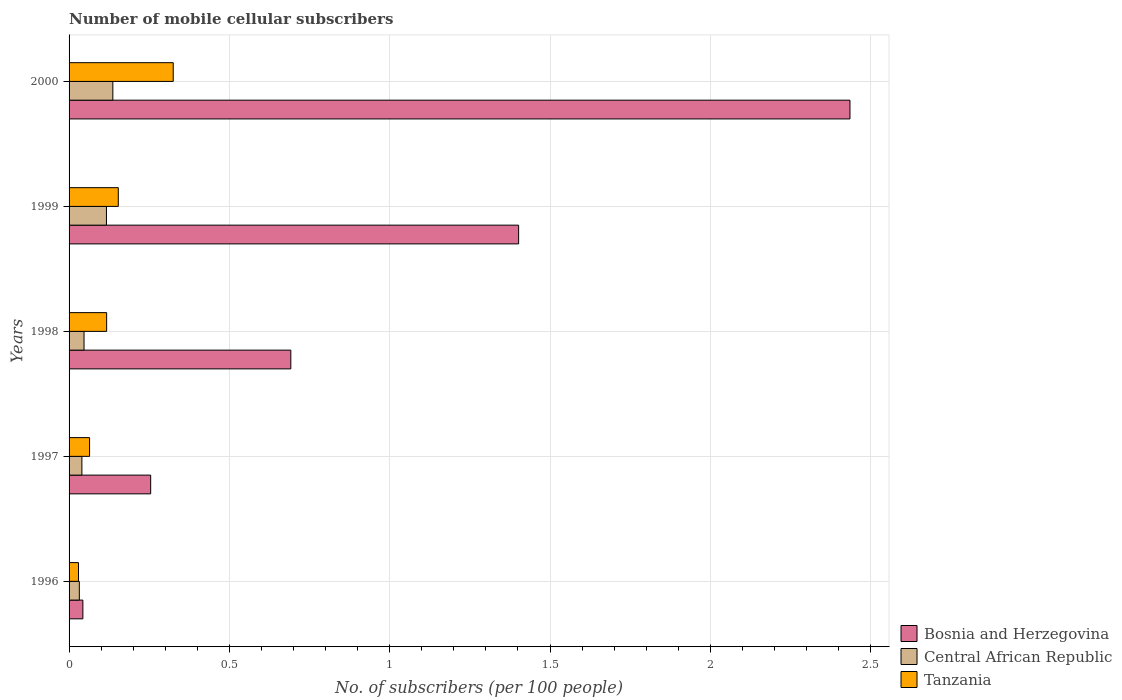How many bars are there on the 5th tick from the top?
Give a very brief answer. 3. How many bars are there on the 5th tick from the bottom?
Ensure brevity in your answer.  3. What is the label of the 5th group of bars from the top?
Ensure brevity in your answer.  1996. What is the number of mobile cellular subscribers in Tanzania in 2000?
Make the answer very short. 0.32. Across all years, what is the maximum number of mobile cellular subscribers in Tanzania?
Your answer should be very brief. 0.32. Across all years, what is the minimum number of mobile cellular subscribers in Tanzania?
Your answer should be very brief. 0.03. What is the total number of mobile cellular subscribers in Central African Republic in the graph?
Keep it short and to the point. 0.37. What is the difference between the number of mobile cellular subscribers in Bosnia and Herzegovina in 1997 and that in 1998?
Give a very brief answer. -0.44. What is the difference between the number of mobile cellular subscribers in Bosnia and Herzegovina in 1998 and the number of mobile cellular subscribers in Tanzania in 1999?
Offer a very short reply. 0.54. What is the average number of mobile cellular subscribers in Central African Republic per year?
Give a very brief answer. 0.07. In the year 1996, what is the difference between the number of mobile cellular subscribers in Bosnia and Herzegovina and number of mobile cellular subscribers in Tanzania?
Ensure brevity in your answer.  0.01. In how many years, is the number of mobile cellular subscribers in Central African Republic greater than 1 ?
Provide a succinct answer. 0. What is the ratio of the number of mobile cellular subscribers in Tanzania in 1996 to that in 1998?
Your response must be concise. 0.25. Is the difference between the number of mobile cellular subscribers in Bosnia and Herzegovina in 1997 and 1999 greater than the difference between the number of mobile cellular subscribers in Tanzania in 1997 and 1999?
Ensure brevity in your answer.  No. What is the difference between the highest and the second highest number of mobile cellular subscribers in Central African Republic?
Offer a very short reply. 0.02. What is the difference between the highest and the lowest number of mobile cellular subscribers in Central African Republic?
Ensure brevity in your answer.  0.1. In how many years, is the number of mobile cellular subscribers in Bosnia and Herzegovina greater than the average number of mobile cellular subscribers in Bosnia and Herzegovina taken over all years?
Ensure brevity in your answer.  2. What does the 3rd bar from the top in 1999 represents?
Provide a succinct answer. Bosnia and Herzegovina. What does the 1st bar from the bottom in 1998 represents?
Give a very brief answer. Bosnia and Herzegovina. Are all the bars in the graph horizontal?
Offer a terse response. Yes. How many years are there in the graph?
Give a very brief answer. 5. Are the values on the major ticks of X-axis written in scientific E-notation?
Provide a succinct answer. No. Does the graph contain any zero values?
Provide a short and direct response. No. Does the graph contain grids?
Your answer should be very brief. Yes. How many legend labels are there?
Ensure brevity in your answer.  3. What is the title of the graph?
Make the answer very short. Number of mobile cellular subscribers. What is the label or title of the X-axis?
Ensure brevity in your answer.  No. of subscribers (per 100 people). What is the No. of subscribers (per 100 people) of Bosnia and Herzegovina in 1996?
Provide a short and direct response. 0.04. What is the No. of subscribers (per 100 people) of Central African Republic in 1996?
Ensure brevity in your answer.  0.03. What is the No. of subscribers (per 100 people) in Tanzania in 1996?
Your answer should be very brief. 0.03. What is the No. of subscribers (per 100 people) of Bosnia and Herzegovina in 1997?
Your answer should be very brief. 0.25. What is the No. of subscribers (per 100 people) of Central African Republic in 1997?
Your response must be concise. 0.04. What is the No. of subscribers (per 100 people) in Tanzania in 1997?
Provide a succinct answer. 0.06. What is the No. of subscribers (per 100 people) of Bosnia and Herzegovina in 1998?
Provide a short and direct response. 0.69. What is the No. of subscribers (per 100 people) in Central African Republic in 1998?
Give a very brief answer. 0.05. What is the No. of subscribers (per 100 people) of Tanzania in 1998?
Offer a very short reply. 0.12. What is the No. of subscribers (per 100 people) in Bosnia and Herzegovina in 1999?
Your response must be concise. 1.4. What is the No. of subscribers (per 100 people) in Central African Republic in 1999?
Keep it short and to the point. 0.12. What is the No. of subscribers (per 100 people) of Tanzania in 1999?
Your response must be concise. 0.15. What is the No. of subscribers (per 100 people) of Bosnia and Herzegovina in 2000?
Your answer should be very brief. 2.44. What is the No. of subscribers (per 100 people) of Central African Republic in 2000?
Keep it short and to the point. 0.14. What is the No. of subscribers (per 100 people) of Tanzania in 2000?
Offer a very short reply. 0.32. Across all years, what is the maximum No. of subscribers (per 100 people) in Bosnia and Herzegovina?
Your response must be concise. 2.44. Across all years, what is the maximum No. of subscribers (per 100 people) in Central African Republic?
Your answer should be compact. 0.14. Across all years, what is the maximum No. of subscribers (per 100 people) of Tanzania?
Give a very brief answer. 0.32. Across all years, what is the minimum No. of subscribers (per 100 people) in Bosnia and Herzegovina?
Keep it short and to the point. 0.04. Across all years, what is the minimum No. of subscribers (per 100 people) in Central African Republic?
Your answer should be compact. 0.03. Across all years, what is the minimum No. of subscribers (per 100 people) in Tanzania?
Your response must be concise. 0.03. What is the total No. of subscribers (per 100 people) in Bosnia and Herzegovina in the graph?
Keep it short and to the point. 4.83. What is the total No. of subscribers (per 100 people) of Central African Republic in the graph?
Make the answer very short. 0.37. What is the total No. of subscribers (per 100 people) in Tanzania in the graph?
Provide a short and direct response. 0.69. What is the difference between the No. of subscribers (per 100 people) in Bosnia and Herzegovina in 1996 and that in 1997?
Make the answer very short. -0.21. What is the difference between the No. of subscribers (per 100 people) in Central African Republic in 1996 and that in 1997?
Provide a short and direct response. -0.01. What is the difference between the No. of subscribers (per 100 people) in Tanzania in 1996 and that in 1997?
Give a very brief answer. -0.03. What is the difference between the No. of subscribers (per 100 people) of Bosnia and Herzegovina in 1996 and that in 1998?
Your response must be concise. -0.65. What is the difference between the No. of subscribers (per 100 people) of Central African Republic in 1996 and that in 1998?
Make the answer very short. -0.01. What is the difference between the No. of subscribers (per 100 people) of Tanzania in 1996 and that in 1998?
Offer a terse response. -0.09. What is the difference between the No. of subscribers (per 100 people) of Bosnia and Herzegovina in 1996 and that in 1999?
Make the answer very short. -1.36. What is the difference between the No. of subscribers (per 100 people) of Central African Republic in 1996 and that in 1999?
Give a very brief answer. -0.08. What is the difference between the No. of subscribers (per 100 people) of Tanzania in 1996 and that in 1999?
Give a very brief answer. -0.12. What is the difference between the No. of subscribers (per 100 people) in Bosnia and Herzegovina in 1996 and that in 2000?
Give a very brief answer. -2.39. What is the difference between the No. of subscribers (per 100 people) of Central African Republic in 1996 and that in 2000?
Offer a very short reply. -0.1. What is the difference between the No. of subscribers (per 100 people) of Tanzania in 1996 and that in 2000?
Your response must be concise. -0.3. What is the difference between the No. of subscribers (per 100 people) in Bosnia and Herzegovina in 1997 and that in 1998?
Offer a very short reply. -0.44. What is the difference between the No. of subscribers (per 100 people) of Central African Republic in 1997 and that in 1998?
Your answer should be compact. -0.01. What is the difference between the No. of subscribers (per 100 people) of Tanzania in 1997 and that in 1998?
Your answer should be very brief. -0.05. What is the difference between the No. of subscribers (per 100 people) in Bosnia and Herzegovina in 1997 and that in 1999?
Provide a short and direct response. -1.15. What is the difference between the No. of subscribers (per 100 people) in Central African Republic in 1997 and that in 1999?
Give a very brief answer. -0.08. What is the difference between the No. of subscribers (per 100 people) in Tanzania in 1997 and that in 1999?
Give a very brief answer. -0.09. What is the difference between the No. of subscribers (per 100 people) in Bosnia and Herzegovina in 1997 and that in 2000?
Offer a very short reply. -2.18. What is the difference between the No. of subscribers (per 100 people) of Central African Republic in 1997 and that in 2000?
Make the answer very short. -0.1. What is the difference between the No. of subscribers (per 100 people) of Tanzania in 1997 and that in 2000?
Your response must be concise. -0.26. What is the difference between the No. of subscribers (per 100 people) in Bosnia and Herzegovina in 1998 and that in 1999?
Give a very brief answer. -0.71. What is the difference between the No. of subscribers (per 100 people) of Central African Republic in 1998 and that in 1999?
Provide a short and direct response. -0.07. What is the difference between the No. of subscribers (per 100 people) of Tanzania in 1998 and that in 1999?
Keep it short and to the point. -0.04. What is the difference between the No. of subscribers (per 100 people) of Bosnia and Herzegovina in 1998 and that in 2000?
Offer a very short reply. -1.74. What is the difference between the No. of subscribers (per 100 people) in Central African Republic in 1998 and that in 2000?
Offer a terse response. -0.09. What is the difference between the No. of subscribers (per 100 people) in Tanzania in 1998 and that in 2000?
Your answer should be very brief. -0.21. What is the difference between the No. of subscribers (per 100 people) in Bosnia and Herzegovina in 1999 and that in 2000?
Keep it short and to the point. -1.03. What is the difference between the No. of subscribers (per 100 people) in Central African Republic in 1999 and that in 2000?
Keep it short and to the point. -0.02. What is the difference between the No. of subscribers (per 100 people) in Tanzania in 1999 and that in 2000?
Offer a terse response. -0.17. What is the difference between the No. of subscribers (per 100 people) in Bosnia and Herzegovina in 1996 and the No. of subscribers (per 100 people) in Central African Republic in 1997?
Keep it short and to the point. 0. What is the difference between the No. of subscribers (per 100 people) in Bosnia and Herzegovina in 1996 and the No. of subscribers (per 100 people) in Tanzania in 1997?
Offer a terse response. -0.02. What is the difference between the No. of subscribers (per 100 people) in Central African Republic in 1996 and the No. of subscribers (per 100 people) in Tanzania in 1997?
Provide a short and direct response. -0.03. What is the difference between the No. of subscribers (per 100 people) in Bosnia and Herzegovina in 1996 and the No. of subscribers (per 100 people) in Central African Republic in 1998?
Offer a very short reply. -0. What is the difference between the No. of subscribers (per 100 people) in Bosnia and Herzegovina in 1996 and the No. of subscribers (per 100 people) in Tanzania in 1998?
Provide a succinct answer. -0.07. What is the difference between the No. of subscribers (per 100 people) of Central African Republic in 1996 and the No. of subscribers (per 100 people) of Tanzania in 1998?
Ensure brevity in your answer.  -0.09. What is the difference between the No. of subscribers (per 100 people) of Bosnia and Herzegovina in 1996 and the No. of subscribers (per 100 people) of Central African Republic in 1999?
Your response must be concise. -0.07. What is the difference between the No. of subscribers (per 100 people) in Bosnia and Herzegovina in 1996 and the No. of subscribers (per 100 people) in Tanzania in 1999?
Offer a terse response. -0.11. What is the difference between the No. of subscribers (per 100 people) of Central African Republic in 1996 and the No. of subscribers (per 100 people) of Tanzania in 1999?
Ensure brevity in your answer.  -0.12. What is the difference between the No. of subscribers (per 100 people) of Bosnia and Herzegovina in 1996 and the No. of subscribers (per 100 people) of Central African Republic in 2000?
Your answer should be very brief. -0.09. What is the difference between the No. of subscribers (per 100 people) in Bosnia and Herzegovina in 1996 and the No. of subscribers (per 100 people) in Tanzania in 2000?
Your response must be concise. -0.28. What is the difference between the No. of subscribers (per 100 people) of Central African Republic in 1996 and the No. of subscribers (per 100 people) of Tanzania in 2000?
Offer a terse response. -0.29. What is the difference between the No. of subscribers (per 100 people) in Bosnia and Herzegovina in 1997 and the No. of subscribers (per 100 people) in Central African Republic in 1998?
Make the answer very short. 0.21. What is the difference between the No. of subscribers (per 100 people) in Bosnia and Herzegovina in 1997 and the No. of subscribers (per 100 people) in Tanzania in 1998?
Provide a short and direct response. 0.14. What is the difference between the No. of subscribers (per 100 people) of Central African Republic in 1997 and the No. of subscribers (per 100 people) of Tanzania in 1998?
Your response must be concise. -0.08. What is the difference between the No. of subscribers (per 100 people) in Bosnia and Herzegovina in 1997 and the No. of subscribers (per 100 people) in Central African Republic in 1999?
Make the answer very short. 0.14. What is the difference between the No. of subscribers (per 100 people) of Bosnia and Herzegovina in 1997 and the No. of subscribers (per 100 people) of Tanzania in 1999?
Ensure brevity in your answer.  0.1. What is the difference between the No. of subscribers (per 100 people) in Central African Republic in 1997 and the No. of subscribers (per 100 people) in Tanzania in 1999?
Provide a succinct answer. -0.11. What is the difference between the No. of subscribers (per 100 people) in Bosnia and Herzegovina in 1997 and the No. of subscribers (per 100 people) in Central African Republic in 2000?
Give a very brief answer. 0.12. What is the difference between the No. of subscribers (per 100 people) in Bosnia and Herzegovina in 1997 and the No. of subscribers (per 100 people) in Tanzania in 2000?
Ensure brevity in your answer.  -0.07. What is the difference between the No. of subscribers (per 100 people) of Central African Republic in 1997 and the No. of subscribers (per 100 people) of Tanzania in 2000?
Your response must be concise. -0.28. What is the difference between the No. of subscribers (per 100 people) of Bosnia and Herzegovina in 1998 and the No. of subscribers (per 100 people) of Central African Republic in 1999?
Provide a short and direct response. 0.57. What is the difference between the No. of subscribers (per 100 people) of Bosnia and Herzegovina in 1998 and the No. of subscribers (per 100 people) of Tanzania in 1999?
Provide a succinct answer. 0.54. What is the difference between the No. of subscribers (per 100 people) in Central African Republic in 1998 and the No. of subscribers (per 100 people) in Tanzania in 1999?
Give a very brief answer. -0.11. What is the difference between the No. of subscribers (per 100 people) of Bosnia and Herzegovina in 1998 and the No. of subscribers (per 100 people) of Central African Republic in 2000?
Your answer should be very brief. 0.56. What is the difference between the No. of subscribers (per 100 people) of Bosnia and Herzegovina in 1998 and the No. of subscribers (per 100 people) of Tanzania in 2000?
Make the answer very short. 0.37. What is the difference between the No. of subscribers (per 100 people) in Central African Republic in 1998 and the No. of subscribers (per 100 people) in Tanzania in 2000?
Provide a succinct answer. -0.28. What is the difference between the No. of subscribers (per 100 people) of Bosnia and Herzegovina in 1999 and the No. of subscribers (per 100 people) of Central African Republic in 2000?
Your response must be concise. 1.27. What is the difference between the No. of subscribers (per 100 people) of Bosnia and Herzegovina in 1999 and the No. of subscribers (per 100 people) of Tanzania in 2000?
Offer a terse response. 1.08. What is the difference between the No. of subscribers (per 100 people) in Central African Republic in 1999 and the No. of subscribers (per 100 people) in Tanzania in 2000?
Keep it short and to the point. -0.21. What is the average No. of subscribers (per 100 people) of Bosnia and Herzegovina per year?
Make the answer very short. 0.97. What is the average No. of subscribers (per 100 people) of Central African Republic per year?
Keep it short and to the point. 0.07. What is the average No. of subscribers (per 100 people) in Tanzania per year?
Your answer should be compact. 0.14. In the year 1996, what is the difference between the No. of subscribers (per 100 people) of Bosnia and Herzegovina and No. of subscribers (per 100 people) of Central African Republic?
Your answer should be very brief. 0.01. In the year 1996, what is the difference between the No. of subscribers (per 100 people) in Bosnia and Herzegovina and No. of subscribers (per 100 people) in Tanzania?
Your response must be concise. 0.01. In the year 1996, what is the difference between the No. of subscribers (per 100 people) of Central African Republic and No. of subscribers (per 100 people) of Tanzania?
Give a very brief answer. 0. In the year 1997, what is the difference between the No. of subscribers (per 100 people) of Bosnia and Herzegovina and No. of subscribers (per 100 people) of Central African Republic?
Offer a terse response. 0.21. In the year 1997, what is the difference between the No. of subscribers (per 100 people) of Bosnia and Herzegovina and No. of subscribers (per 100 people) of Tanzania?
Your response must be concise. 0.19. In the year 1997, what is the difference between the No. of subscribers (per 100 people) of Central African Republic and No. of subscribers (per 100 people) of Tanzania?
Offer a terse response. -0.02. In the year 1998, what is the difference between the No. of subscribers (per 100 people) in Bosnia and Herzegovina and No. of subscribers (per 100 people) in Central African Republic?
Your answer should be very brief. 0.64. In the year 1998, what is the difference between the No. of subscribers (per 100 people) in Bosnia and Herzegovina and No. of subscribers (per 100 people) in Tanzania?
Offer a terse response. 0.57. In the year 1998, what is the difference between the No. of subscribers (per 100 people) of Central African Republic and No. of subscribers (per 100 people) of Tanzania?
Give a very brief answer. -0.07. In the year 1999, what is the difference between the No. of subscribers (per 100 people) in Bosnia and Herzegovina and No. of subscribers (per 100 people) in Central African Republic?
Provide a short and direct response. 1.29. In the year 1999, what is the difference between the No. of subscribers (per 100 people) in Bosnia and Herzegovina and No. of subscribers (per 100 people) in Tanzania?
Give a very brief answer. 1.25. In the year 1999, what is the difference between the No. of subscribers (per 100 people) in Central African Republic and No. of subscribers (per 100 people) in Tanzania?
Offer a very short reply. -0.04. In the year 2000, what is the difference between the No. of subscribers (per 100 people) in Bosnia and Herzegovina and No. of subscribers (per 100 people) in Central African Republic?
Provide a succinct answer. 2.3. In the year 2000, what is the difference between the No. of subscribers (per 100 people) of Bosnia and Herzegovina and No. of subscribers (per 100 people) of Tanzania?
Ensure brevity in your answer.  2.11. In the year 2000, what is the difference between the No. of subscribers (per 100 people) in Central African Republic and No. of subscribers (per 100 people) in Tanzania?
Offer a terse response. -0.19. What is the ratio of the No. of subscribers (per 100 people) in Bosnia and Herzegovina in 1996 to that in 1997?
Give a very brief answer. 0.17. What is the ratio of the No. of subscribers (per 100 people) of Central African Republic in 1996 to that in 1997?
Your answer should be compact. 0.8. What is the ratio of the No. of subscribers (per 100 people) in Tanzania in 1996 to that in 1997?
Your answer should be compact. 0.46. What is the ratio of the No. of subscribers (per 100 people) in Bosnia and Herzegovina in 1996 to that in 1998?
Keep it short and to the point. 0.06. What is the ratio of the No. of subscribers (per 100 people) in Central African Republic in 1996 to that in 1998?
Provide a short and direct response. 0.68. What is the ratio of the No. of subscribers (per 100 people) in Tanzania in 1996 to that in 1998?
Ensure brevity in your answer.  0.25. What is the ratio of the No. of subscribers (per 100 people) in Bosnia and Herzegovina in 1996 to that in 1999?
Provide a short and direct response. 0.03. What is the ratio of the No. of subscribers (per 100 people) of Central African Republic in 1996 to that in 1999?
Your answer should be very brief. 0.27. What is the ratio of the No. of subscribers (per 100 people) in Tanzania in 1996 to that in 1999?
Your answer should be compact. 0.19. What is the ratio of the No. of subscribers (per 100 people) of Bosnia and Herzegovina in 1996 to that in 2000?
Make the answer very short. 0.02. What is the ratio of the No. of subscribers (per 100 people) in Central African Republic in 1996 to that in 2000?
Provide a short and direct response. 0.23. What is the ratio of the No. of subscribers (per 100 people) of Tanzania in 1996 to that in 2000?
Give a very brief answer. 0.09. What is the ratio of the No. of subscribers (per 100 people) in Bosnia and Herzegovina in 1997 to that in 1998?
Your answer should be compact. 0.37. What is the ratio of the No. of subscribers (per 100 people) of Central African Republic in 1997 to that in 1998?
Offer a terse response. 0.86. What is the ratio of the No. of subscribers (per 100 people) of Tanzania in 1997 to that in 1998?
Offer a very short reply. 0.55. What is the ratio of the No. of subscribers (per 100 people) in Bosnia and Herzegovina in 1997 to that in 1999?
Offer a very short reply. 0.18. What is the ratio of the No. of subscribers (per 100 people) of Central African Republic in 1997 to that in 1999?
Provide a short and direct response. 0.34. What is the ratio of the No. of subscribers (per 100 people) in Tanzania in 1997 to that in 1999?
Your answer should be very brief. 0.42. What is the ratio of the No. of subscribers (per 100 people) of Bosnia and Herzegovina in 1997 to that in 2000?
Offer a terse response. 0.1. What is the ratio of the No. of subscribers (per 100 people) of Central African Republic in 1997 to that in 2000?
Provide a short and direct response. 0.29. What is the ratio of the No. of subscribers (per 100 people) of Tanzania in 1997 to that in 2000?
Your response must be concise. 0.2. What is the ratio of the No. of subscribers (per 100 people) in Bosnia and Herzegovina in 1998 to that in 1999?
Provide a succinct answer. 0.49. What is the ratio of the No. of subscribers (per 100 people) of Central African Republic in 1998 to that in 1999?
Your answer should be very brief. 0.4. What is the ratio of the No. of subscribers (per 100 people) in Tanzania in 1998 to that in 1999?
Provide a succinct answer. 0.76. What is the ratio of the No. of subscribers (per 100 people) in Bosnia and Herzegovina in 1998 to that in 2000?
Offer a very short reply. 0.28. What is the ratio of the No. of subscribers (per 100 people) of Central African Republic in 1998 to that in 2000?
Make the answer very short. 0.34. What is the ratio of the No. of subscribers (per 100 people) of Tanzania in 1998 to that in 2000?
Ensure brevity in your answer.  0.36. What is the ratio of the No. of subscribers (per 100 people) of Bosnia and Herzegovina in 1999 to that in 2000?
Make the answer very short. 0.58. What is the ratio of the No. of subscribers (per 100 people) in Central African Republic in 1999 to that in 2000?
Ensure brevity in your answer.  0.85. What is the ratio of the No. of subscribers (per 100 people) of Tanzania in 1999 to that in 2000?
Give a very brief answer. 0.47. What is the difference between the highest and the second highest No. of subscribers (per 100 people) of Bosnia and Herzegovina?
Keep it short and to the point. 1.03. What is the difference between the highest and the second highest No. of subscribers (per 100 people) in Central African Republic?
Your answer should be compact. 0.02. What is the difference between the highest and the second highest No. of subscribers (per 100 people) of Tanzania?
Make the answer very short. 0.17. What is the difference between the highest and the lowest No. of subscribers (per 100 people) of Bosnia and Herzegovina?
Your answer should be very brief. 2.39. What is the difference between the highest and the lowest No. of subscribers (per 100 people) of Central African Republic?
Offer a very short reply. 0.1. What is the difference between the highest and the lowest No. of subscribers (per 100 people) in Tanzania?
Make the answer very short. 0.3. 